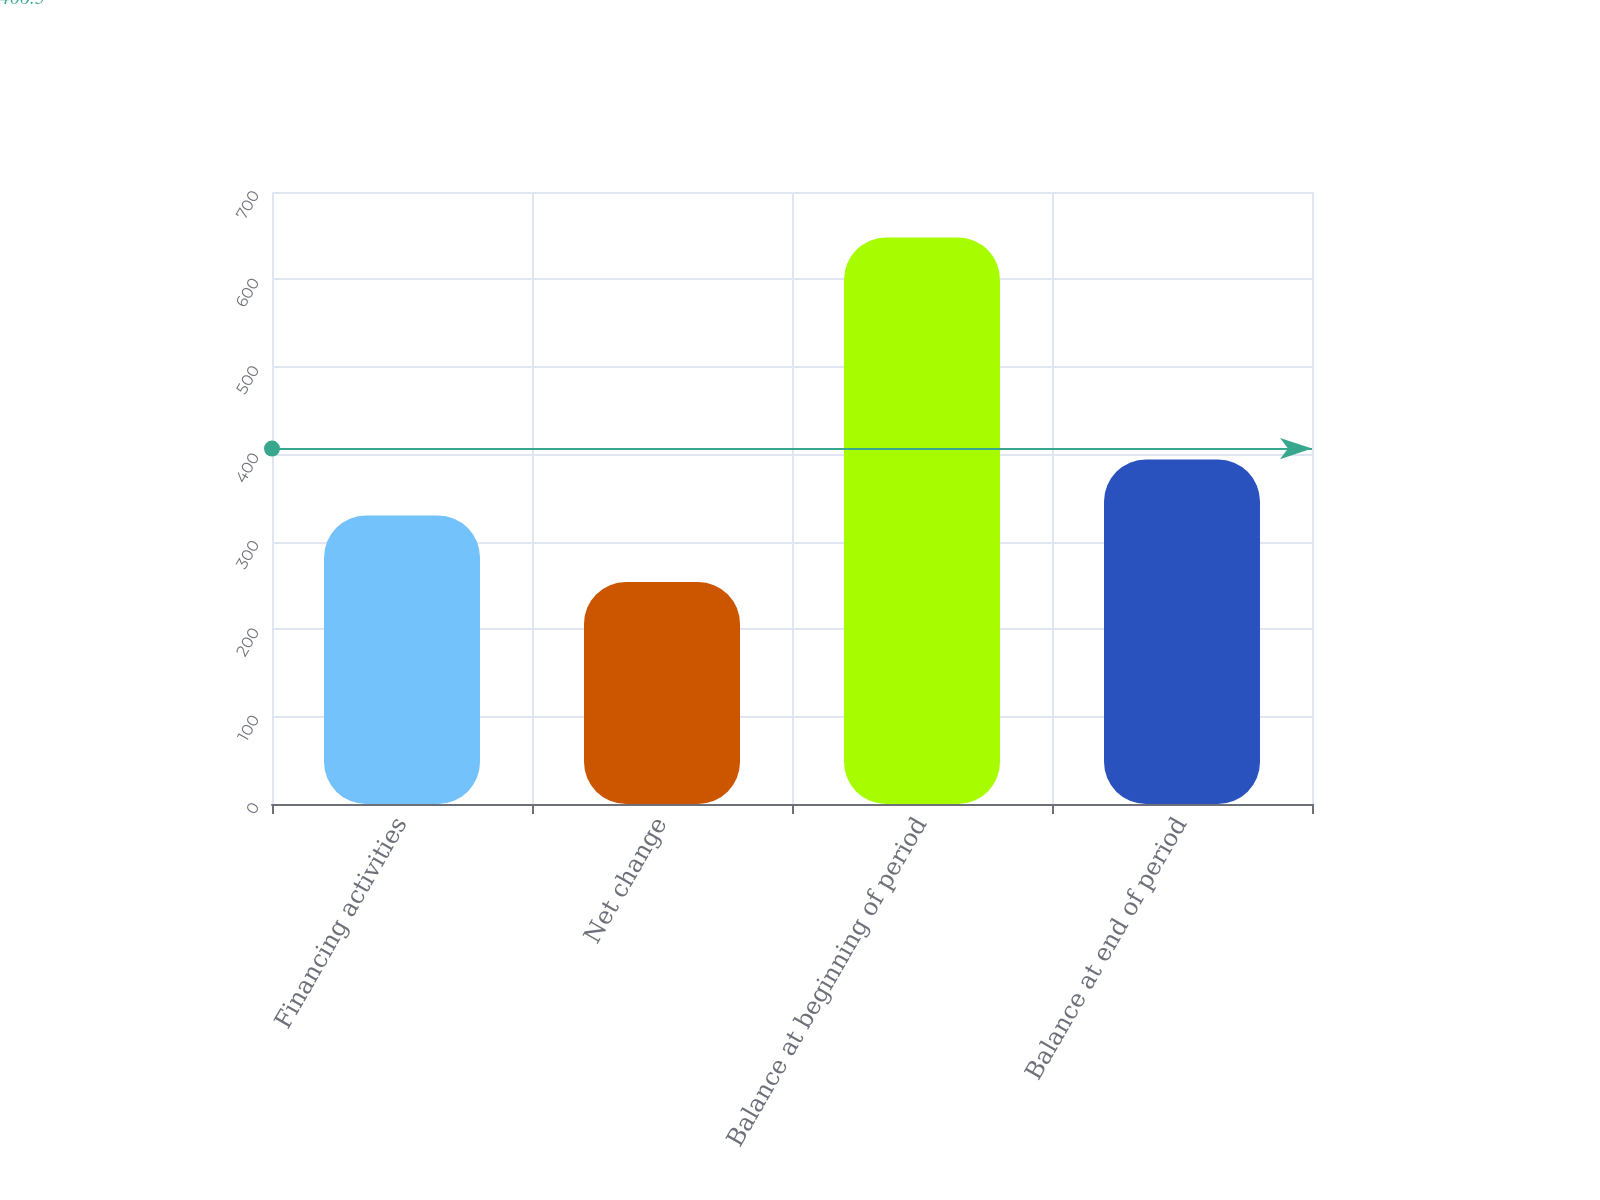<chart> <loc_0><loc_0><loc_500><loc_500><bar_chart><fcel>Financing activities<fcel>Net change<fcel>Balance at beginning of period<fcel>Balance at end of period<nl><fcel>330<fcel>254<fcel>648<fcel>394<nl></chart> 